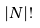<formula> <loc_0><loc_0><loc_500><loc_500>| N | !</formula> 